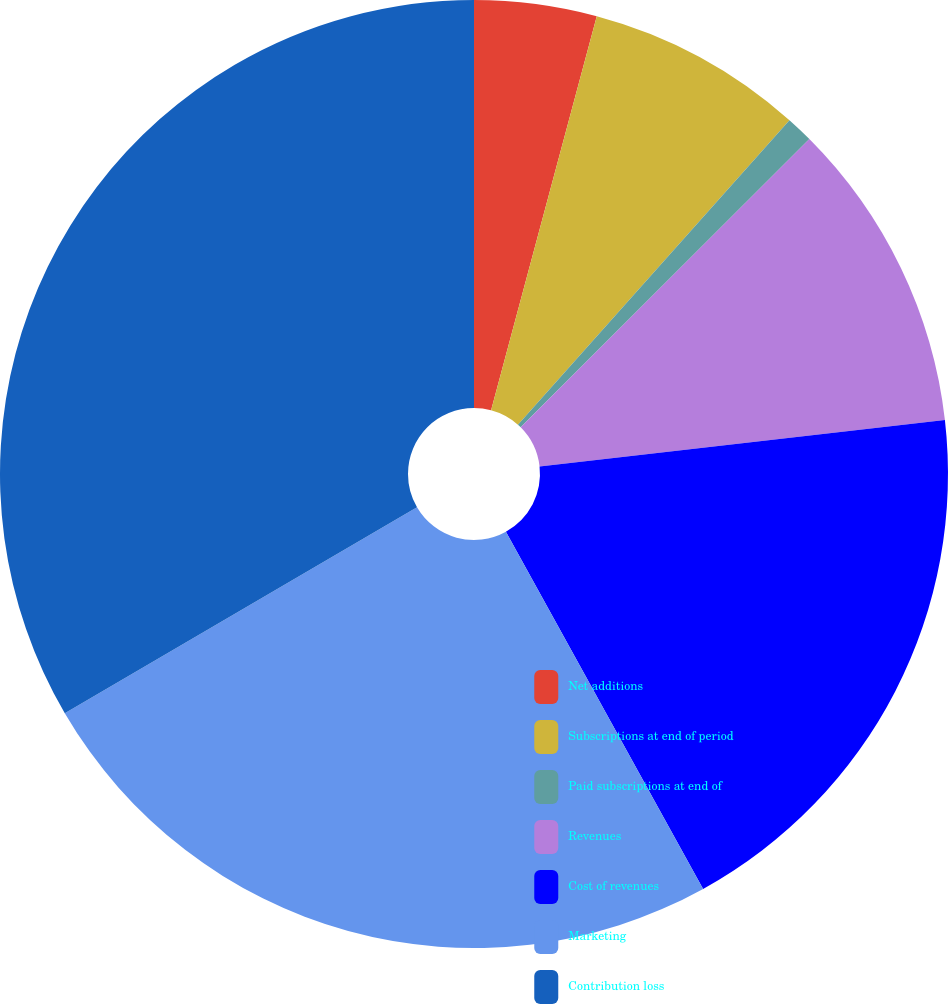<chart> <loc_0><loc_0><loc_500><loc_500><pie_chart><fcel>Net additions<fcel>Subscriptions at end of period<fcel>Paid subscriptions at end of<fcel>Revenues<fcel>Cost of revenues<fcel>Marketing<fcel>Contribution loss<nl><fcel>4.17%<fcel>7.42%<fcel>0.92%<fcel>10.67%<fcel>18.79%<fcel>24.61%<fcel>33.42%<nl></chart> 